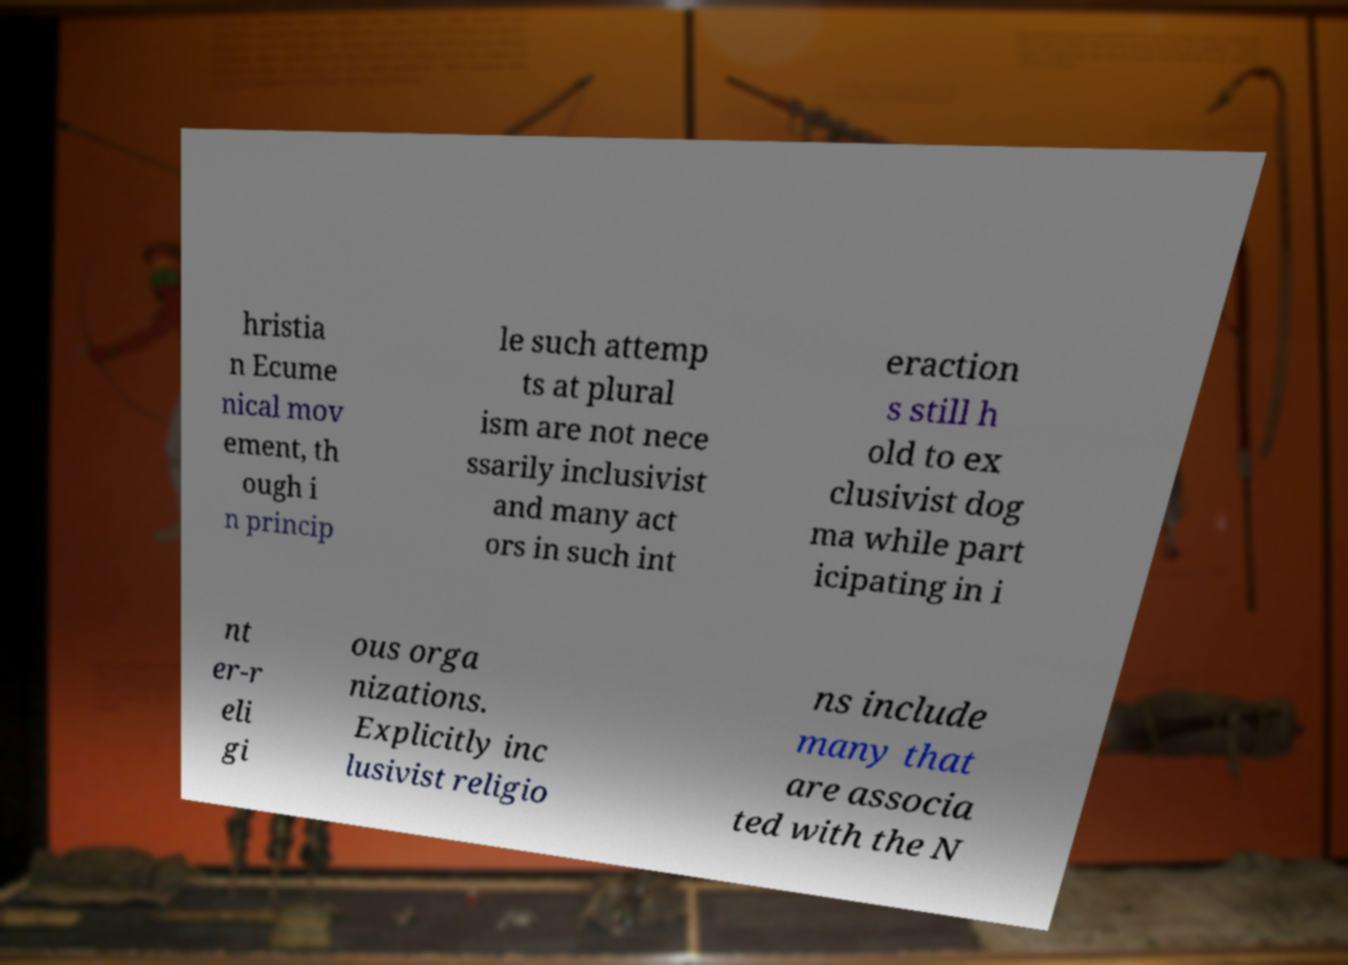What messages or text are displayed in this image? I need them in a readable, typed format. hristia n Ecume nical mov ement, th ough i n princip le such attemp ts at plural ism are not nece ssarily inclusivist and many act ors in such int eraction s still h old to ex clusivist dog ma while part icipating in i nt er-r eli gi ous orga nizations. Explicitly inc lusivist religio ns include many that are associa ted with the N 